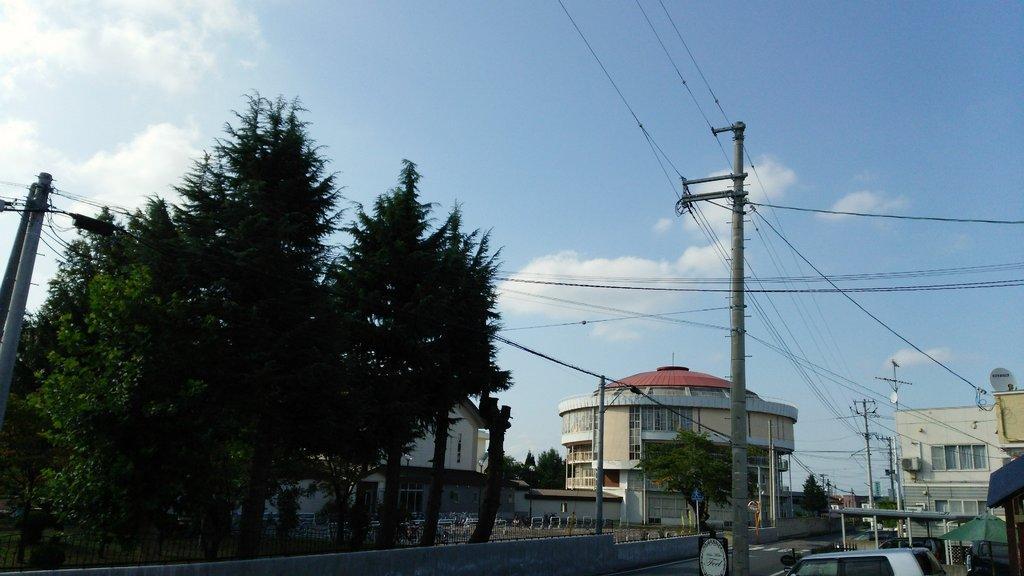In one or two sentences, can you explain what this image depicts? In this image in the front there is a car and in the center there are trees, poles. In the background there are buildings and there are wires, trees and poles and the sky is cloudy. 